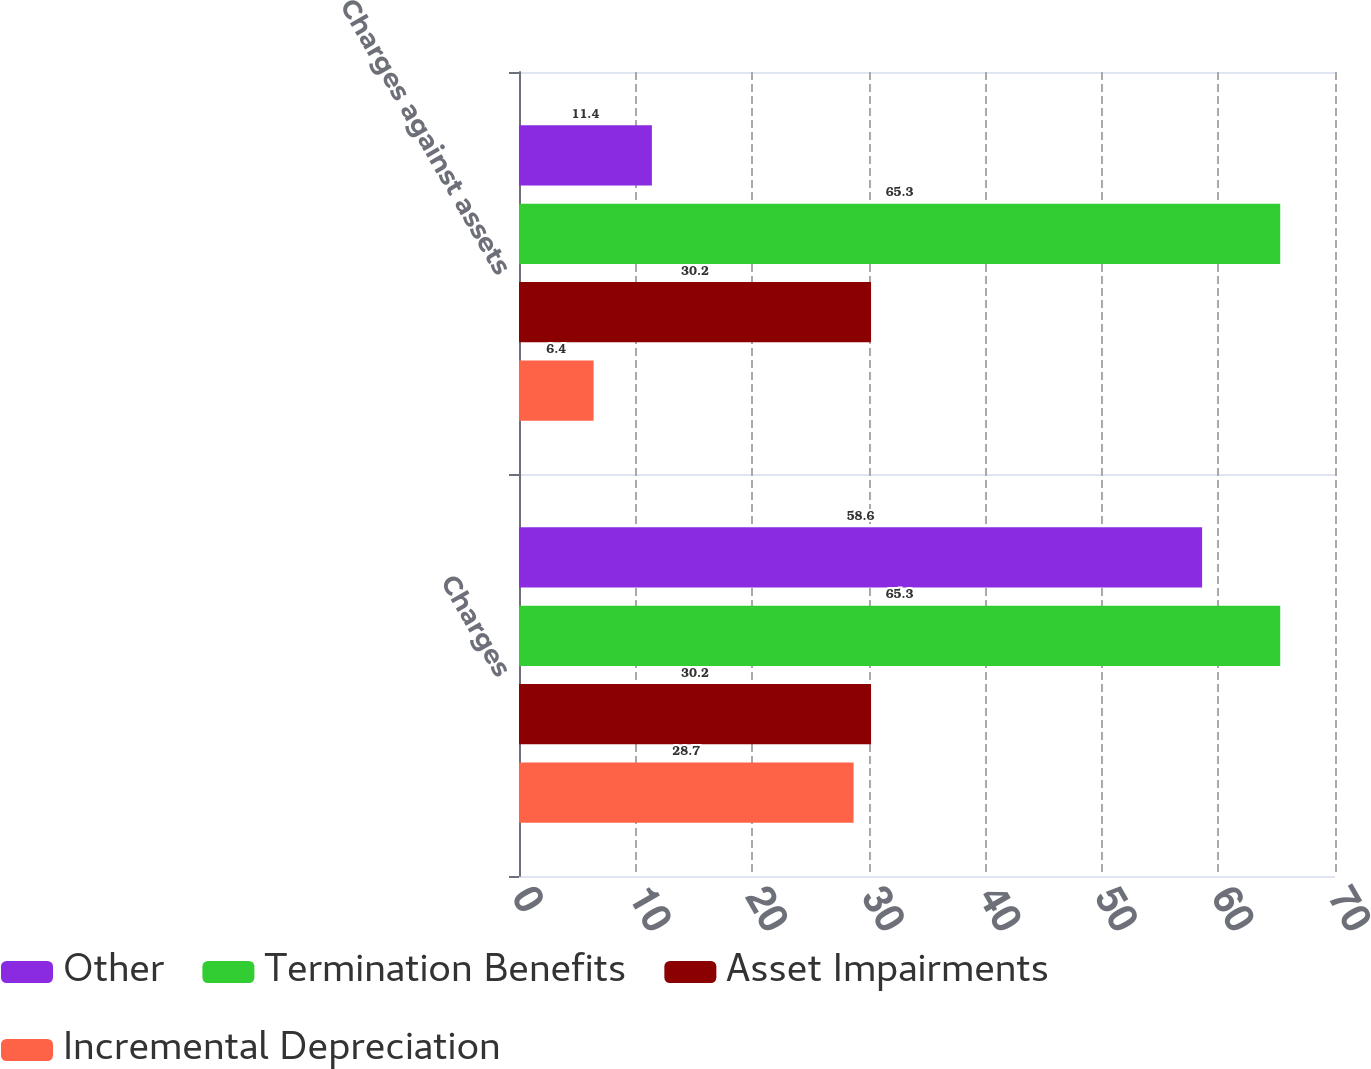Convert chart. <chart><loc_0><loc_0><loc_500><loc_500><stacked_bar_chart><ecel><fcel>Charges<fcel>Charges against assets<nl><fcel>Other<fcel>58.6<fcel>11.4<nl><fcel>Termination Benefits<fcel>65.3<fcel>65.3<nl><fcel>Asset Impairments<fcel>30.2<fcel>30.2<nl><fcel>Incremental Depreciation<fcel>28.7<fcel>6.4<nl></chart> 